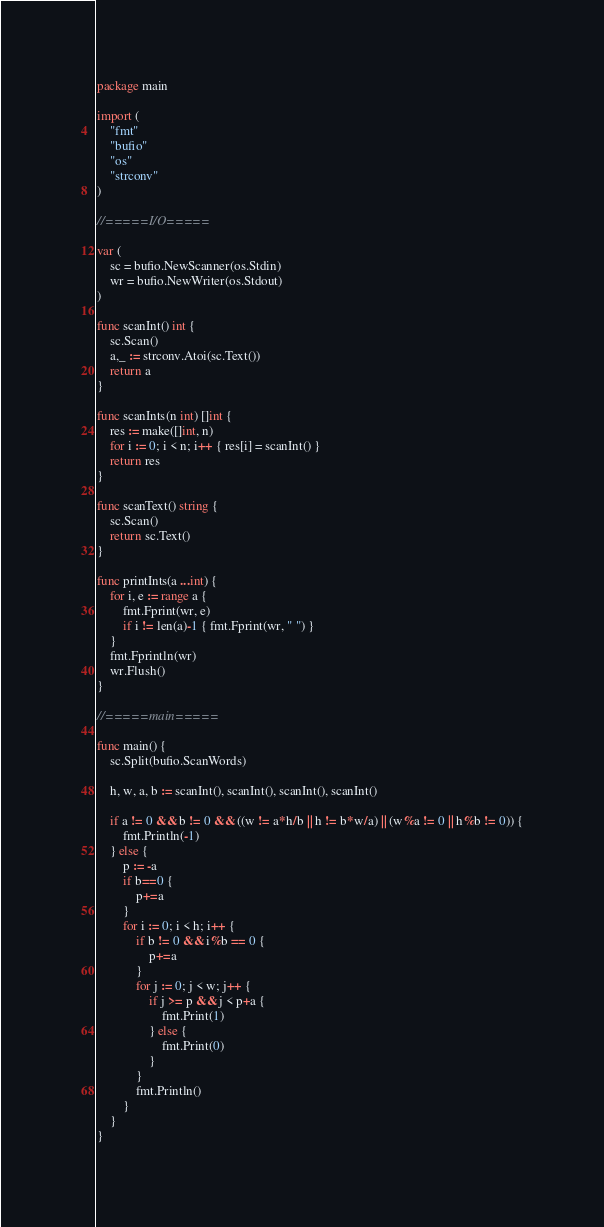<code> <loc_0><loc_0><loc_500><loc_500><_Go_>package main

import (
	"fmt"
	"bufio"
	"os"
	"strconv"
)

//=====I/O=====

var (
	sc = bufio.NewScanner(os.Stdin)
	wr = bufio.NewWriter(os.Stdout)
)

func scanInt() int {
	sc.Scan()
	a,_ := strconv.Atoi(sc.Text())
	return a
}

func scanInts(n int) []int {
	res := make([]int, n)
	for i := 0; i < n; i++ { res[i] = scanInt() }
	return res
}

func scanText() string {
	sc.Scan()
	return sc.Text()
}

func printInts(a ...int) {
	for i, e := range a {
		fmt.Fprint(wr, e)
		if i != len(a)-1 { fmt.Fprint(wr, " ") }
	}
	fmt.Fprintln(wr)
	wr.Flush()
}

//=====main=====

func main() {
	sc.Split(bufio.ScanWords)

	h, w, a, b := scanInt(), scanInt(), scanInt(), scanInt()

	if a != 0 && b != 0 && ((w != a*h/b || h != b*w/a) || (w%a != 0 || h%b != 0)) {
		fmt.Println(-1)
	} else {
		p := -a
		if b==0 {
			p+=a
		}
		for i := 0; i < h; i++ {
			if b != 0 && i%b == 0 {
				p+=a
			}
			for j := 0; j < w; j++ {
				if j >= p && j < p+a {
					fmt.Print(1)
				} else {
					fmt.Print(0)
				}
			}
			fmt.Println()
		}
	}
}
</code> 